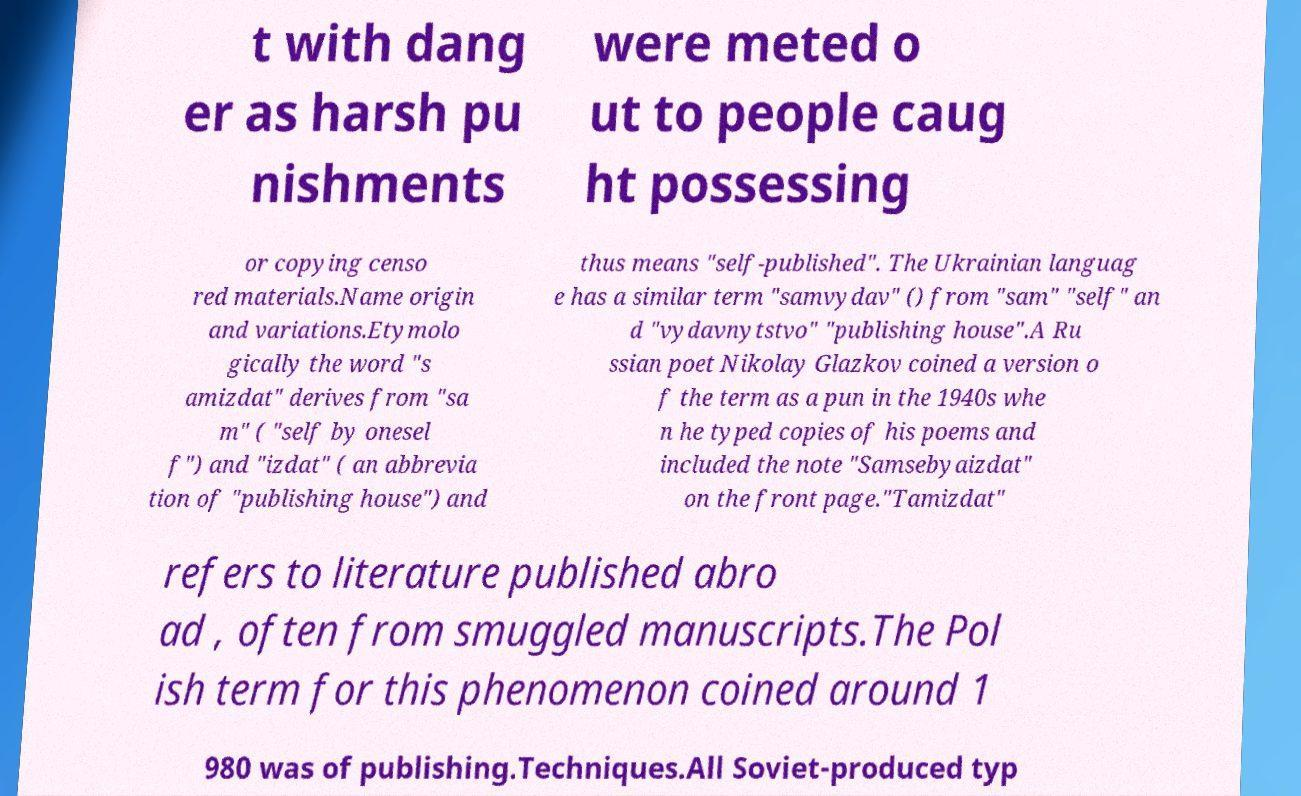For documentation purposes, I need the text within this image transcribed. Could you provide that? t with dang er as harsh pu nishments were meted o ut to people caug ht possessing or copying censo red materials.Name origin and variations.Etymolo gically the word "s amizdat" derives from "sa m" ( "self by onesel f") and "izdat" ( an abbrevia tion of "publishing house") and thus means "self-published". The Ukrainian languag e has a similar term "samvydav" () from "sam" "self" an d "vydavnytstvo" "publishing house".A Ru ssian poet Nikolay Glazkov coined a version o f the term as a pun in the 1940s whe n he typed copies of his poems and included the note "Samsebyaizdat" on the front page."Tamizdat" refers to literature published abro ad , often from smuggled manuscripts.The Pol ish term for this phenomenon coined around 1 980 was of publishing.Techniques.All Soviet-produced typ 